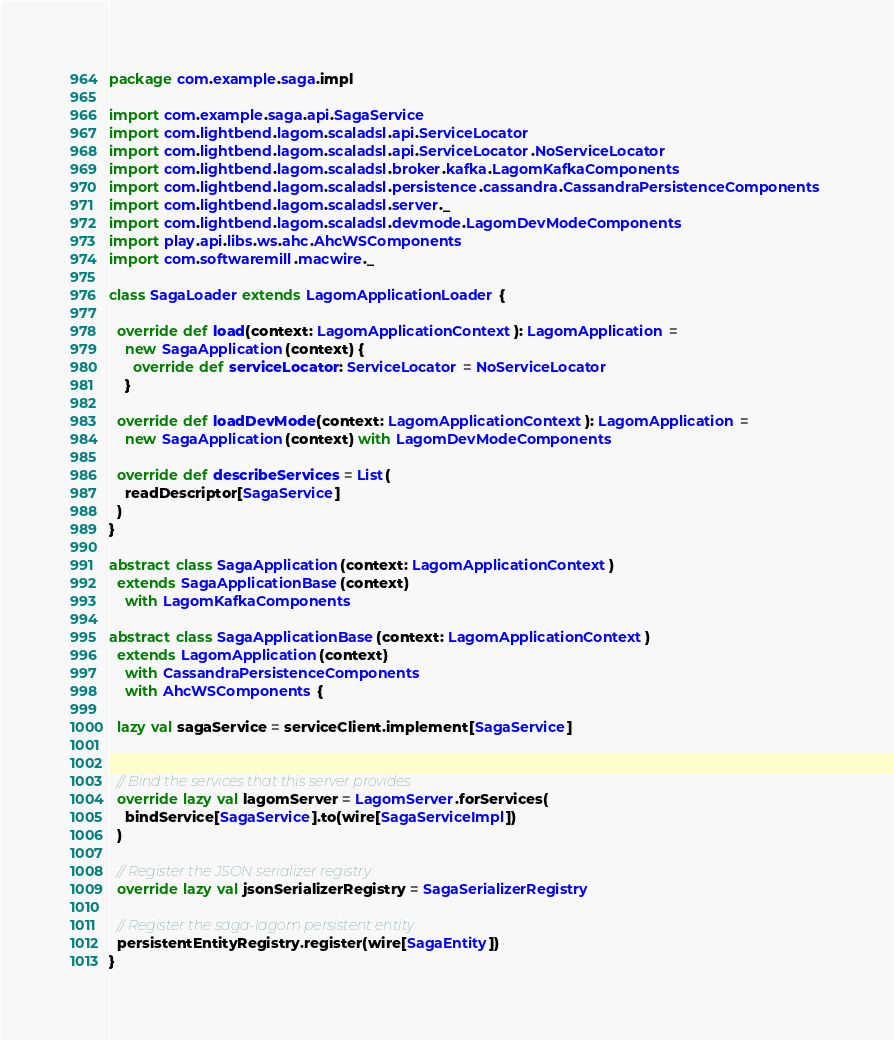Convert code to text. <code><loc_0><loc_0><loc_500><loc_500><_Scala_>package com.example.saga.impl

import com.example.saga.api.SagaService
import com.lightbend.lagom.scaladsl.api.ServiceLocator
import com.lightbend.lagom.scaladsl.api.ServiceLocator.NoServiceLocator
import com.lightbend.lagom.scaladsl.broker.kafka.LagomKafkaComponents
import com.lightbend.lagom.scaladsl.persistence.cassandra.CassandraPersistenceComponents
import com.lightbend.lagom.scaladsl.server._
import com.lightbend.lagom.scaladsl.devmode.LagomDevModeComponents
import play.api.libs.ws.ahc.AhcWSComponents
import com.softwaremill.macwire._

class SagaLoader extends LagomApplicationLoader {

  override def load(context: LagomApplicationContext): LagomApplication =
    new SagaApplication(context) {
      override def serviceLocator: ServiceLocator = NoServiceLocator
    }

  override def loadDevMode(context: LagomApplicationContext): LagomApplication =
    new SagaApplication(context) with LagomDevModeComponents

  override def describeServices = List(
    readDescriptor[SagaService]
  )
}

abstract class SagaApplication(context: LagomApplicationContext)
  extends SagaApplicationBase(context)
    with LagomKafkaComponents

abstract class SagaApplicationBase(context: LagomApplicationContext)
  extends LagomApplication(context)
    with CassandraPersistenceComponents
    with AhcWSComponents {

  lazy val sagaService = serviceClient.implement[SagaService]


  // Bind the services that this server provides
  override lazy val lagomServer = LagomServer.forServices(
    bindService[SagaService].to(wire[SagaServiceImpl])
  )

  // Register the JSON serializer registry
  override lazy val jsonSerializerRegistry = SagaSerializerRegistry

  // Register the saga-lagom persistent entity
  persistentEntityRegistry.register(wire[SagaEntity])
}

</code> 